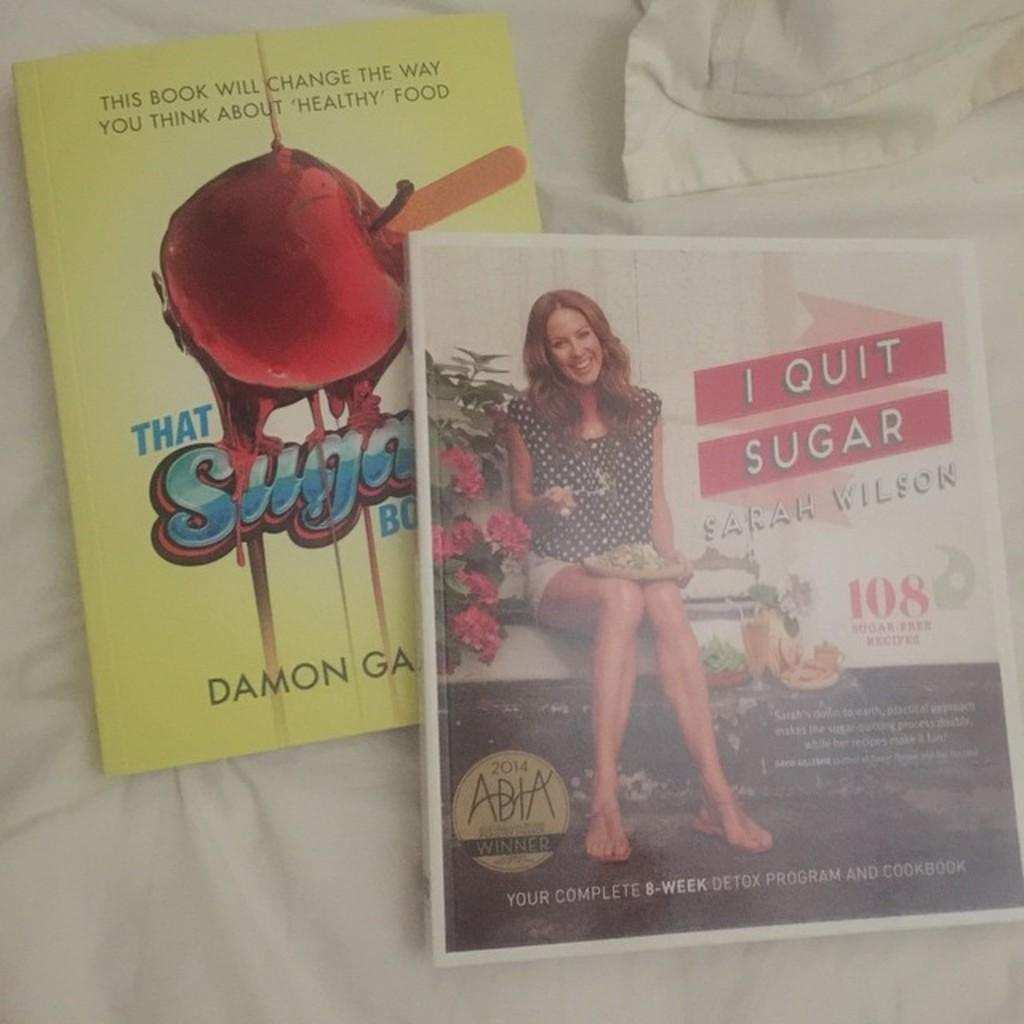What is the color of the cloth in the image? The cloth in the image is white. What objects are placed on the white cloth? There are two books on the white cloth. What type of soap is being used to clean the books in the image? There is no soap or cleaning activity depicted in the image; it only shows two books on a white cloth. 